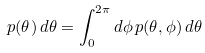<formula> <loc_0><loc_0><loc_500><loc_500>p ( \theta ) \, d \theta = \int _ { 0 } ^ { 2 \pi } d \phi \, p ( \theta , \phi ) \, d \theta</formula> 